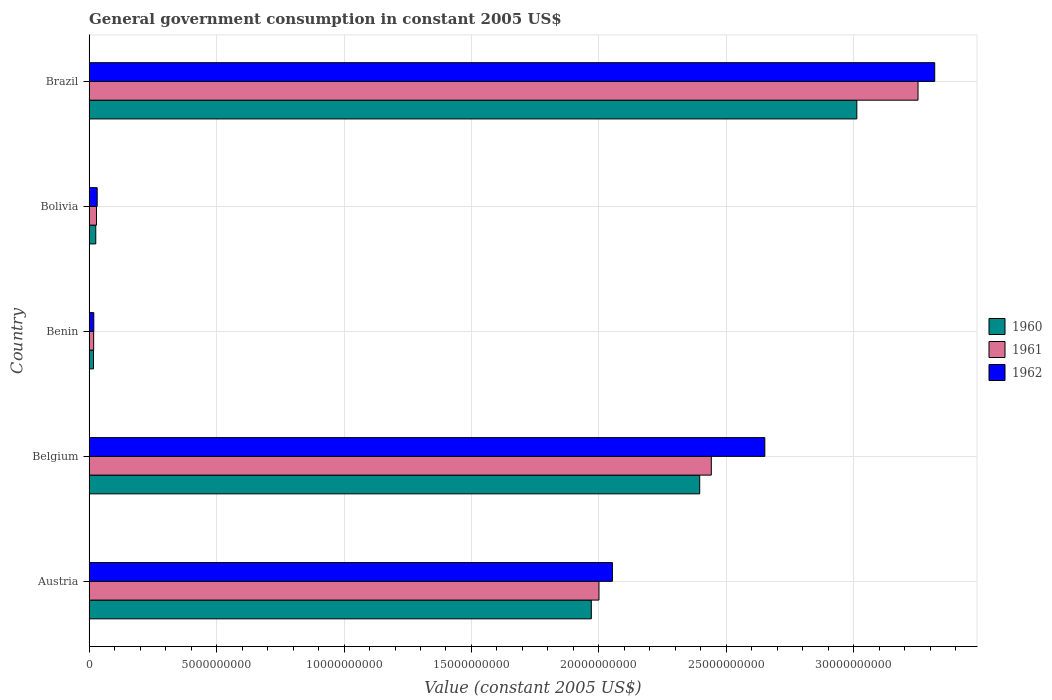How many different coloured bars are there?
Your answer should be compact. 3. How many groups of bars are there?
Provide a short and direct response. 5. Are the number of bars per tick equal to the number of legend labels?
Your answer should be compact. Yes. Are the number of bars on each tick of the Y-axis equal?
Your answer should be compact. Yes. How many bars are there on the 5th tick from the bottom?
Offer a terse response. 3. What is the label of the 5th group of bars from the top?
Offer a very short reply. Austria. What is the government conusmption in 1961 in Brazil?
Your response must be concise. 3.25e+1. Across all countries, what is the maximum government conusmption in 1960?
Provide a succinct answer. 3.01e+1. Across all countries, what is the minimum government conusmption in 1961?
Ensure brevity in your answer.  1.79e+08. In which country was the government conusmption in 1960 minimum?
Make the answer very short. Benin. What is the total government conusmption in 1962 in the graph?
Keep it short and to the point. 8.07e+1. What is the difference between the government conusmption in 1960 in Bolivia and that in Brazil?
Offer a very short reply. -2.99e+1. What is the difference between the government conusmption in 1962 in Bolivia and the government conusmption in 1960 in Benin?
Your answer should be compact. 1.44e+08. What is the average government conusmption in 1961 per country?
Provide a succinct answer. 1.55e+1. What is the difference between the government conusmption in 1961 and government conusmption in 1960 in Bolivia?
Provide a short and direct response. 2.92e+07. In how many countries, is the government conusmption in 1962 greater than 27000000000 US$?
Provide a short and direct response. 1. What is the ratio of the government conusmption in 1960 in Benin to that in Bolivia?
Offer a terse response. 0.66. Is the government conusmption in 1961 in Austria less than that in Brazil?
Ensure brevity in your answer.  Yes. Is the difference between the government conusmption in 1961 in Belgium and Bolivia greater than the difference between the government conusmption in 1960 in Belgium and Bolivia?
Make the answer very short. Yes. What is the difference between the highest and the second highest government conusmption in 1962?
Offer a very short reply. 6.66e+09. What is the difference between the highest and the lowest government conusmption in 1962?
Ensure brevity in your answer.  3.30e+1. Does the graph contain any zero values?
Keep it short and to the point. No. Does the graph contain grids?
Your response must be concise. Yes. Where does the legend appear in the graph?
Your answer should be compact. Center right. How many legend labels are there?
Make the answer very short. 3. How are the legend labels stacked?
Offer a very short reply. Vertical. What is the title of the graph?
Provide a short and direct response. General government consumption in constant 2005 US$. Does "1984" appear as one of the legend labels in the graph?
Provide a succinct answer. No. What is the label or title of the X-axis?
Provide a short and direct response. Value (constant 2005 US$). What is the label or title of the Y-axis?
Give a very brief answer. Country. What is the Value (constant 2005 US$) in 1960 in Austria?
Provide a succinct answer. 1.97e+1. What is the Value (constant 2005 US$) in 1961 in Austria?
Your answer should be compact. 2.00e+1. What is the Value (constant 2005 US$) of 1962 in Austria?
Provide a short and direct response. 2.05e+1. What is the Value (constant 2005 US$) of 1960 in Belgium?
Your answer should be compact. 2.40e+1. What is the Value (constant 2005 US$) of 1961 in Belgium?
Give a very brief answer. 2.44e+1. What is the Value (constant 2005 US$) in 1962 in Belgium?
Offer a terse response. 2.65e+1. What is the Value (constant 2005 US$) in 1960 in Benin?
Your answer should be compact. 1.73e+08. What is the Value (constant 2005 US$) of 1961 in Benin?
Your answer should be compact. 1.79e+08. What is the Value (constant 2005 US$) in 1962 in Benin?
Offer a very short reply. 1.85e+08. What is the Value (constant 2005 US$) of 1960 in Bolivia?
Provide a short and direct response. 2.61e+08. What is the Value (constant 2005 US$) in 1961 in Bolivia?
Your answer should be very brief. 2.91e+08. What is the Value (constant 2005 US$) in 1962 in Bolivia?
Make the answer very short. 3.18e+08. What is the Value (constant 2005 US$) in 1960 in Brazil?
Provide a short and direct response. 3.01e+1. What is the Value (constant 2005 US$) in 1961 in Brazil?
Offer a very short reply. 3.25e+1. What is the Value (constant 2005 US$) of 1962 in Brazil?
Your response must be concise. 3.32e+1. Across all countries, what is the maximum Value (constant 2005 US$) in 1960?
Ensure brevity in your answer.  3.01e+1. Across all countries, what is the maximum Value (constant 2005 US$) of 1961?
Offer a very short reply. 3.25e+1. Across all countries, what is the maximum Value (constant 2005 US$) in 1962?
Offer a terse response. 3.32e+1. Across all countries, what is the minimum Value (constant 2005 US$) in 1960?
Give a very brief answer. 1.73e+08. Across all countries, what is the minimum Value (constant 2005 US$) of 1961?
Your answer should be very brief. 1.79e+08. Across all countries, what is the minimum Value (constant 2005 US$) of 1962?
Your answer should be compact. 1.85e+08. What is the total Value (constant 2005 US$) in 1960 in the graph?
Provide a succinct answer. 7.42e+1. What is the total Value (constant 2005 US$) of 1961 in the graph?
Ensure brevity in your answer.  7.74e+1. What is the total Value (constant 2005 US$) in 1962 in the graph?
Keep it short and to the point. 8.07e+1. What is the difference between the Value (constant 2005 US$) in 1960 in Austria and that in Belgium?
Your answer should be very brief. -4.25e+09. What is the difference between the Value (constant 2005 US$) in 1961 in Austria and that in Belgium?
Ensure brevity in your answer.  -4.41e+09. What is the difference between the Value (constant 2005 US$) in 1962 in Austria and that in Belgium?
Provide a succinct answer. -5.98e+09. What is the difference between the Value (constant 2005 US$) in 1960 in Austria and that in Benin?
Provide a short and direct response. 1.95e+1. What is the difference between the Value (constant 2005 US$) of 1961 in Austria and that in Benin?
Your answer should be compact. 1.98e+1. What is the difference between the Value (constant 2005 US$) of 1962 in Austria and that in Benin?
Provide a short and direct response. 2.03e+1. What is the difference between the Value (constant 2005 US$) of 1960 in Austria and that in Bolivia?
Provide a succinct answer. 1.94e+1. What is the difference between the Value (constant 2005 US$) of 1961 in Austria and that in Bolivia?
Provide a succinct answer. 1.97e+1. What is the difference between the Value (constant 2005 US$) in 1962 in Austria and that in Bolivia?
Give a very brief answer. 2.02e+1. What is the difference between the Value (constant 2005 US$) of 1960 in Austria and that in Brazil?
Offer a very short reply. -1.04e+1. What is the difference between the Value (constant 2005 US$) of 1961 in Austria and that in Brazil?
Ensure brevity in your answer.  -1.25e+1. What is the difference between the Value (constant 2005 US$) in 1962 in Austria and that in Brazil?
Make the answer very short. -1.26e+1. What is the difference between the Value (constant 2005 US$) of 1960 in Belgium and that in Benin?
Your answer should be very brief. 2.38e+1. What is the difference between the Value (constant 2005 US$) of 1961 in Belgium and that in Benin?
Your answer should be compact. 2.42e+1. What is the difference between the Value (constant 2005 US$) of 1962 in Belgium and that in Benin?
Ensure brevity in your answer.  2.63e+1. What is the difference between the Value (constant 2005 US$) in 1960 in Belgium and that in Bolivia?
Provide a succinct answer. 2.37e+1. What is the difference between the Value (constant 2005 US$) of 1961 in Belgium and that in Bolivia?
Offer a terse response. 2.41e+1. What is the difference between the Value (constant 2005 US$) of 1962 in Belgium and that in Bolivia?
Ensure brevity in your answer.  2.62e+1. What is the difference between the Value (constant 2005 US$) in 1960 in Belgium and that in Brazil?
Keep it short and to the point. -6.16e+09. What is the difference between the Value (constant 2005 US$) in 1961 in Belgium and that in Brazil?
Provide a succinct answer. -8.11e+09. What is the difference between the Value (constant 2005 US$) in 1962 in Belgium and that in Brazil?
Offer a very short reply. -6.66e+09. What is the difference between the Value (constant 2005 US$) in 1960 in Benin and that in Bolivia?
Offer a terse response. -8.81e+07. What is the difference between the Value (constant 2005 US$) of 1961 in Benin and that in Bolivia?
Your answer should be very brief. -1.12e+08. What is the difference between the Value (constant 2005 US$) in 1962 in Benin and that in Bolivia?
Offer a very short reply. -1.33e+08. What is the difference between the Value (constant 2005 US$) in 1960 in Benin and that in Brazil?
Ensure brevity in your answer.  -2.99e+1. What is the difference between the Value (constant 2005 US$) in 1961 in Benin and that in Brazil?
Your answer should be compact. -3.23e+1. What is the difference between the Value (constant 2005 US$) in 1962 in Benin and that in Brazil?
Make the answer very short. -3.30e+1. What is the difference between the Value (constant 2005 US$) of 1960 in Bolivia and that in Brazil?
Your answer should be compact. -2.99e+1. What is the difference between the Value (constant 2005 US$) in 1961 in Bolivia and that in Brazil?
Give a very brief answer. -3.22e+1. What is the difference between the Value (constant 2005 US$) in 1962 in Bolivia and that in Brazil?
Your answer should be compact. -3.29e+1. What is the difference between the Value (constant 2005 US$) of 1960 in Austria and the Value (constant 2005 US$) of 1961 in Belgium?
Offer a very short reply. -4.71e+09. What is the difference between the Value (constant 2005 US$) of 1960 in Austria and the Value (constant 2005 US$) of 1962 in Belgium?
Make the answer very short. -6.81e+09. What is the difference between the Value (constant 2005 US$) in 1961 in Austria and the Value (constant 2005 US$) in 1962 in Belgium?
Your answer should be compact. -6.51e+09. What is the difference between the Value (constant 2005 US$) of 1960 in Austria and the Value (constant 2005 US$) of 1961 in Benin?
Give a very brief answer. 1.95e+1. What is the difference between the Value (constant 2005 US$) of 1960 in Austria and the Value (constant 2005 US$) of 1962 in Benin?
Keep it short and to the point. 1.95e+1. What is the difference between the Value (constant 2005 US$) in 1961 in Austria and the Value (constant 2005 US$) in 1962 in Benin?
Provide a succinct answer. 1.98e+1. What is the difference between the Value (constant 2005 US$) of 1960 in Austria and the Value (constant 2005 US$) of 1961 in Bolivia?
Your answer should be very brief. 1.94e+1. What is the difference between the Value (constant 2005 US$) of 1960 in Austria and the Value (constant 2005 US$) of 1962 in Bolivia?
Offer a terse response. 1.94e+1. What is the difference between the Value (constant 2005 US$) of 1961 in Austria and the Value (constant 2005 US$) of 1962 in Bolivia?
Offer a terse response. 1.97e+1. What is the difference between the Value (constant 2005 US$) in 1960 in Austria and the Value (constant 2005 US$) in 1961 in Brazil?
Offer a terse response. -1.28e+1. What is the difference between the Value (constant 2005 US$) in 1960 in Austria and the Value (constant 2005 US$) in 1962 in Brazil?
Give a very brief answer. -1.35e+1. What is the difference between the Value (constant 2005 US$) in 1961 in Austria and the Value (constant 2005 US$) in 1962 in Brazil?
Provide a short and direct response. -1.32e+1. What is the difference between the Value (constant 2005 US$) in 1960 in Belgium and the Value (constant 2005 US$) in 1961 in Benin?
Your answer should be very brief. 2.38e+1. What is the difference between the Value (constant 2005 US$) in 1960 in Belgium and the Value (constant 2005 US$) in 1962 in Benin?
Ensure brevity in your answer.  2.38e+1. What is the difference between the Value (constant 2005 US$) of 1961 in Belgium and the Value (constant 2005 US$) of 1962 in Benin?
Provide a succinct answer. 2.42e+1. What is the difference between the Value (constant 2005 US$) of 1960 in Belgium and the Value (constant 2005 US$) of 1961 in Bolivia?
Your answer should be compact. 2.37e+1. What is the difference between the Value (constant 2005 US$) in 1960 in Belgium and the Value (constant 2005 US$) in 1962 in Bolivia?
Keep it short and to the point. 2.36e+1. What is the difference between the Value (constant 2005 US$) in 1961 in Belgium and the Value (constant 2005 US$) in 1962 in Bolivia?
Your answer should be compact. 2.41e+1. What is the difference between the Value (constant 2005 US$) in 1960 in Belgium and the Value (constant 2005 US$) in 1961 in Brazil?
Your response must be concise. -8.56e+09. What is the difference between the Value (constant 2005 US$) in 1960 in Belgium and the Value (constant 2005 US$) in 1962 in Brazil?
Give a very brief answer. -9.22e+09. What is the difference between the Value (constant 2005 US$) in 1961 in Belgium and the Value (constant 2005 US$) in 1962 in Brazil?
Provide a short and direct response. -8.76e+09. What is the difference between the Value (constant 2005 US$) of 1960 in Benin and the Value (constant 2005 US$) of 1961 in Bolivia?
Ensure brevity in your answer.  -1.17e+08. What is the difference between the Value (constant 2005 US$) of 1960 in Benin and the Value (constant 2005 US$) of 1962 in Bolivia?
Make the answer very short. -1.44e+08. What is the difference between the Value (constant 2005 US$) in 1961 in Benin and the Value (constant 2005 US$) in 1962 in Bolivia?
Your answer should be compact. -1.39e+08. What is the difference between the Value (constant 2005 US$) of 1960 in Benin and the Value (constant 2005 US$) of 1961 in Brazil?
Provide a short and direct response. -3.23e+1. What is the difference between the Value (constant 2005 US$) in 1960 in Benin and the Value (constant 2005 US$) in 1962 in Brazil?
Offer a terse response. -3.30e+1. What is the difference between the Value (constant 2005 US$) of 1961 in Benin and the Value (constant 2005 US$) of 1962 in Brazil?
Make the answer very short. -3.30e+1. What is the difference between the Value (constant 2005 US$) of 1960 in Bolivia and the Value (constant 2005 US$) of 1961 in Brazil?
Your answer should be compact. -3.23e+1. What is the difference between the Value (constant 2005 US$) in 1960 in Bolivia and the Value (constant 2005 US$) in 1962 in Brazil?
Your answer should be very brief. -3.29e+1. What is the difference between the Value (constant 2005 US$) of 1961 in Bolivia and the Value (constant 2005 US$) of 1962 in Brazil?
Give a very brief answer. -3.29e+1. What is the average Value (constant 2005 US$) in 1960 per country?
Keep it short and to the point. 1.48e+1. What is the average Value (constant 2005 US$) of 1961 per country?
Make the answer very short. 1.55e+1. What is the average Value (constant 2005 US$) of 1962 per country?
Make the answer very short. 1.61e+1. What is the difference between the Value (constant 2005 US$) of 1960 and Value (constant 2005 US$) of 1961 in Austria?
Provide a short and direct response. -3.01e+08. What is the difference between the Value (constant 2005 US$) in 1960 and Value (constant 2005 US$) in 1962 in Austria?
Your answer should be very brief. -8.27e+08. What is the difference between the Value (constant 2005 US$) in 1961 and Value (constant 2005 US$) in 1962 in Austria?
Offer a terse response. -5.26e+08. What is the difference between the Value (constant 2005 US$) of 1960 and Value (constant 2005 US$) of 1961 in Belgium?
Your answer should be compact. -4.56e+08. What is the difference between the Value (constant 2005 US$) in 1960 and Value (constant 2005 US$) in 1962 in Belgium?
Your answer should be very brief. -2.55e+09. What is the difference between the Value (constant 2005 US$) in 1961 and Value (constant 2005 US$) in 1962 in Belgium?
Give a very brief answer. -2.10e+09. What is the difference between the Value (constant 2005 US$) of 1960 and Value (constant 2005 US$) of 1961 in Benin?
Provide a succinct answer. -5.64e+06. What is the difference between the Value (constant 2005 US$) of 1960 and Value (constant 2005 US$) of 1962 in Benin?
Keep it short and to the point. -1.13e+07. What is the difference between the Value (constant 2005 US$) in 1961 and Value (constant 2005 US$) in 1962 in Benin?
Your answer should be compact. -5.64e+06. What is the difference between the Value (constant 2005 US$) of 1960 and Value (constant 2005 US$) of 1961 in Bolivia?
Your response must be concise. -2.92e+07. What is the difference between the Value (constant 2005 US$) in 1960 and Value (constant 2005 US$) in 1962 in Bolivia?
Offer a very short reply. -5.62e+07. What is the difference between the Value (constant 2005 US$) in 1961 and Value (constant 2005 US$) in 1962 in Bolivia?
Offer a very short reply. -2.70e+07. What is the difference between the Value (constant 2005 US$) of 1960 and Value (constant 2005 US$) of 1961 in Brazil?
Give a very brief answer. -2.40e+09. What is the difference between the Value (constant 2005 US$) in 1960 and Value (constant 2005 US$) in 1962 in Brazil?
Ensure brevity in your answer.  -3.06e+09. What is the difference between the Value (constant 2005 US$) in 1961 and Value (constant 2005 US$) in 1962 in Brazil?
Provide a short and direct response. -6.55e+08. What is the ratio of the Value (constant 2005 US$) of 1960 in Austria to that in Belgium?
Provide a succinct answer. 0.82. What is the ratio of the Value (constant 2005 US$) in 1961 in Austria to that in Belgium?
Give a very brief answer. 0.82. What is the ratio of the Value (constant 2005 US$) in 1962 in Austria to that in Belgium?
Offer a very short reply. 0.77. What is the ratio of the Value (constant 2005 US$) in 1960 in Austria to that in Benin?
Ensure brevity in your answer.  113.66. What is the ratio of the Value (constant 2005 US$) of 1961 in Austria to that in Benin?
Give a very brief answer. 111.76. What is the ratio of the Value (constant 2005 US$) of 1962 in Austria to that in Benin?
Your response must be concise. 111.2. What is the ratio of the Value (constant 2005 US$) of 1960 in Austria to that in Bolivia?
Provide a short and direct response. 75.35. What is the ratio of the Value (constant 2005 US$) in 1961 in Austria to that in Bolivia?
Ensure brevity in your answer.  68.81. What is the ratio of the Value (constant 2005 US$) in 1962 in Austria to that in Bolivia?
Give a very brief answer. 64.62. What is the ratio of the Value (constant 2005 US$) of 1960 in Austria to that in Brazil?
Your answer should be very brief. 0.65. What is the ratio of the Value (constant 2005 US$) of 1961 in Austria to that in Brazil?
Keep it short and to the point. 0.62. What is the ratio of the Value (constant 2005 US$) of 1962 in Austria to that in Brazil?
Give a very brief answer. 0.62. What is the ratio of the Value (constant 2005 US$) of 1960 in Belgium to that in Benin?
Keep it short and to the point. 138.18. What is the ratio of the Value (constant 2005 US$) of 1961 in Belgium to that in Benin?
Your answer should be compact. 136.38. What is the ratio of the Value (constant 2005 US$) in 1962 in Belgium to that in Benin?
Offer a terse response. 143.58. What is the ratio of the Value (constant 2005 US$) of 1960 in Belgium to that in Bolivia?
Offer a terse response. 91.61. What is the ratio of the Value (constant 2005 US$) of 1961 in Belgium to that in Bolivia?
Ensure brevity in your answer.  83.97. What is the ratio of the Value (constant 2005 US$) in 1962 in Belgium to that in Bolivia?
Ensure brevity in your answer.  83.45. What is the ratio of the Value (constant 2005 US$) in 1960 in Belgium to that in Brazil?
Provide a short and direct response. 0.8. What is the ratio of the Value (constant 2005 US$) of 1961 in Belgium to that in Brazil?
Ensure brevity in your answer.  0.75. What is the ratio of the Value (constant 2005 US$) in 1962 in Belgium to that in Brazil?
Your response must be concise. 0.8. What is the ratio of the Value (constant 2005 US$) of 1960 in Benin to that in Bolivia?
Offer a very short reply. 0.66. What is the ratio of the Value (constant 2005 US$) of 1961 in Benin to that in Bolivia?
Offer a terse response. 0.62. What is the ratio of the Value (constant 2005 US$) in 1962 in Benin to that in Bolivia?
Ensure brevity in your answer.  0.58. What is the ratio of the Value (constant 2005 US$) of 1960 in Benin to that in Brazil?
Provide a short and direct response. 0.01. What is the ratio of the Value (constant 2005 US$) in 1961 in Benin to that in Brazil?
Your answer should be very brief. 0.01. What is the ratio of the Value (constant 2005 US$) in 1962 in Benin to that in Brazil?
Provide a succinct answer. 0.01. What is the ratio of the Value (constant 2005 US$) in 1960 in Bolivia to that in Brazil?
Make the answer very short. 0.01. What is the ratio of the Value (constant 2005 US$) of 1961 in Bolivia to that in Brazil?
Give a very brief answer. 0.01. What is the ratio of the Value (constant 2005 US$) of 1962 in Bolivia to that in Brazil?
Provide a short and direct response. 0.01. What is the difference between the highest and the second highest Value (constant 2005 US$) of 1960?
Ensure brevity in your answer.  6.16e+09. What is the difference between the highest and the second highest Value (constant 2005 US$) of 1961?
Keep it short and to the point. 8.11e+09. What is the difference between the highest and the second highest Value (constant 2005 US$) of 1962?
Offer a very short reply. 6.66e+09. What is the difference between the highest and the lowest Value (constant 2005 US$) in 1960?
Keep it short and to the point. 2.99e+1. What is the difference between the highest and the lowest Value (constant 2005 US$) of 1961?
Provide a succinct answer. 3.23e+1. What is the difference between the highest and the lowest Value (constant 2005 US$) in 1962?
Provide a short and direct response. 3.30e+1. 